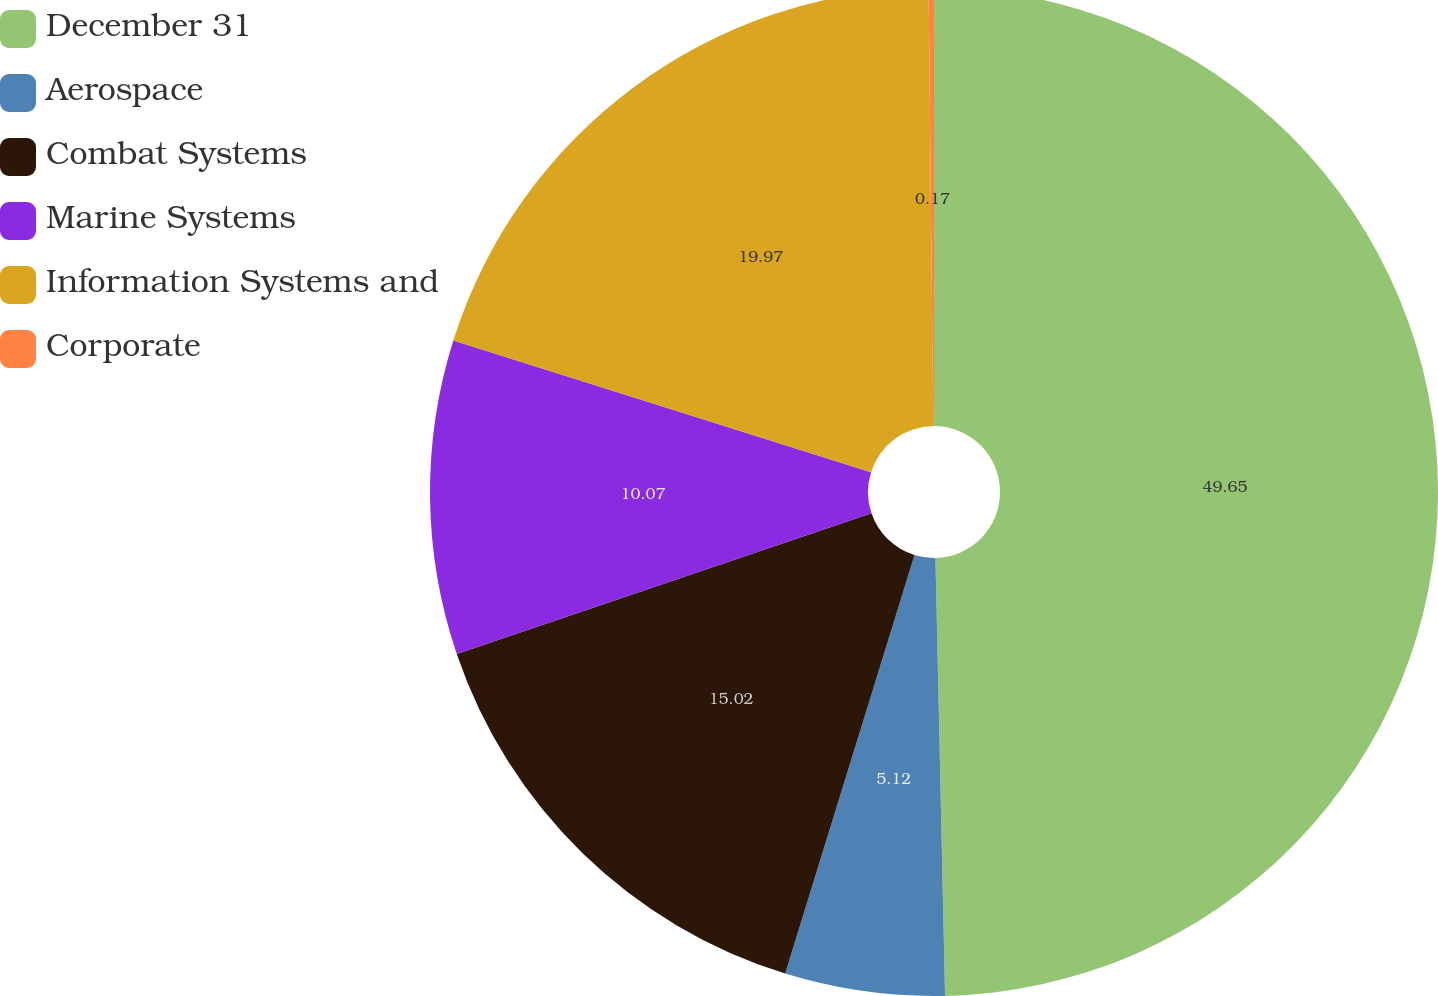Convert chart. <chart><loc_0><loc_0><loc_500><loc_500><pie_chart><fcel>December 31<fcel>Aerospace<fcel>Combat Systems<fcel>Marine Systems<fcel>Information Systems and<fcel>Corporate<nl><fcel>49.65%<fcel>5.12%<fcel>15.02%<fcel>10.07%<fcel>19.97%<fcel>0.17%<nl></chart> 